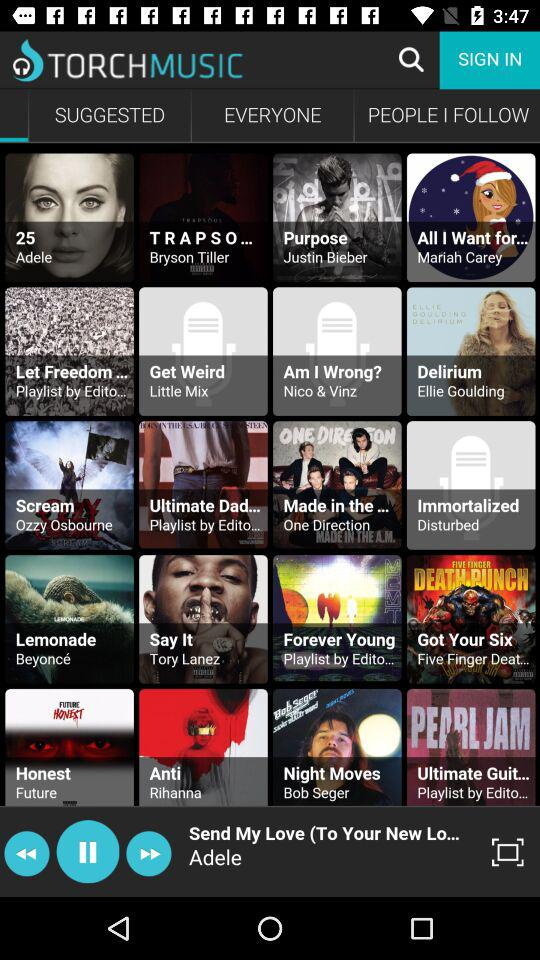Which song is currently playing? The currently playing song is "Send My Love (To Your New Lo...". 